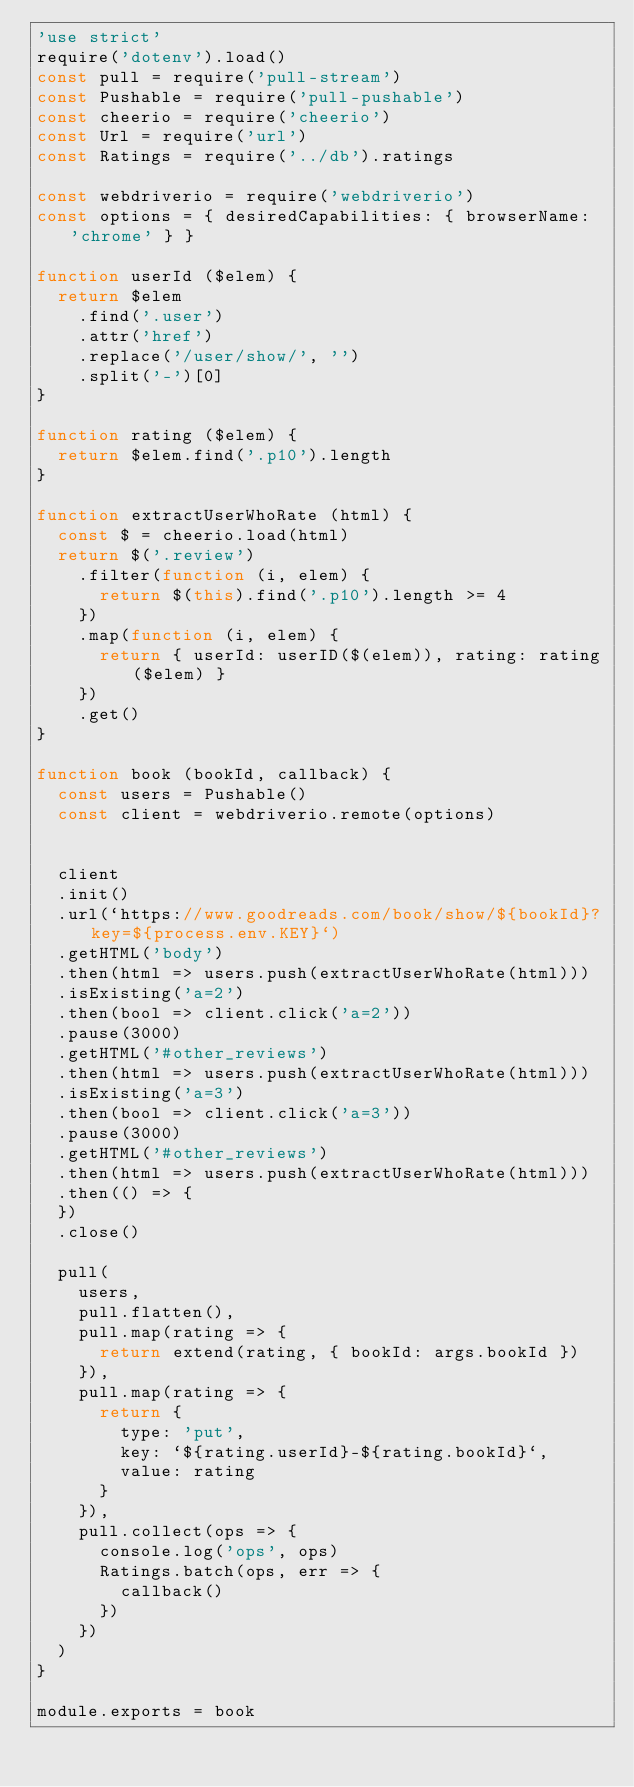<code> <loc_0><loc_0><loc_500><loc_500><_JavaScript_>'use strict'
require('dotenv').load()
const pull = require('pull-stream')
const Pushable = require('pull-pushable')
const cheerio = require('cheerio')
const Url = require('url')
const Ratings = require('../db').ratings

const webdriverio = require('webdriverio')
const options = { desiredCapabilities: { browserName: 'chrome' } }

function userId ($elem) {
  return $elem
    .find('.user')
    .attr('href')
    .replace('/user/show/', '')
    .split('-')[0]
}

function rating ($elem) {
  return $elem.find('.p10').length
}

function extractUserWhoRate (html) {
  const $ = cheerio.load(html)
  return $('.review')
    .filter(function (i, elem) {
      return $(this).find('.p10').length >= 4
    })
    .map(function (i, elem) {
      return { userId: userID($(elem)), rating: rating($elem) } 
    })
    .get()
}

function book (bookId, callback) {
  const users = Pushable()
  const client = webdriverio.remote(options)
    

  client
  .init()
  .url(`https://www.goodreads.com/book/show/${bookId}?key=${process.env.KEY}`)
  .getHTML('body')
  .then(html => users.push(extractUserWhoRate(html)))
  .isExisting('a=2')
  .then(bool => client.click('a=2'))
  .pause(3000)
  .getHTML('#other_reviews')
  .then(html => users.push(extractUserWhoRate(html)))
  .isExisting('a=3')
  .then(bool => client.click('a=3'))
  .pause(3000)
  .getHTML('#other_reviews')
  .then(html => users.push(extractUserWhoRate(html)))
  .then(() => {
  })
  .close()

  pull(
    users,
    pull.flatten(),
    pull.map(rating => {
      return extend(rating, { bookId: args.bookId })
    }),
    pull.map(rating => {
      return {
        type: 'put',
        key: `${rating.userId}-${rating.bookId}`,
        value: rating
      }
    }),
    pull.collect(ops => {
      console.log('ops', ops)
      Ratings.batch(ops, err => {
        callback()            
      })       
    })
  )
}

module.exports = book
</code> 